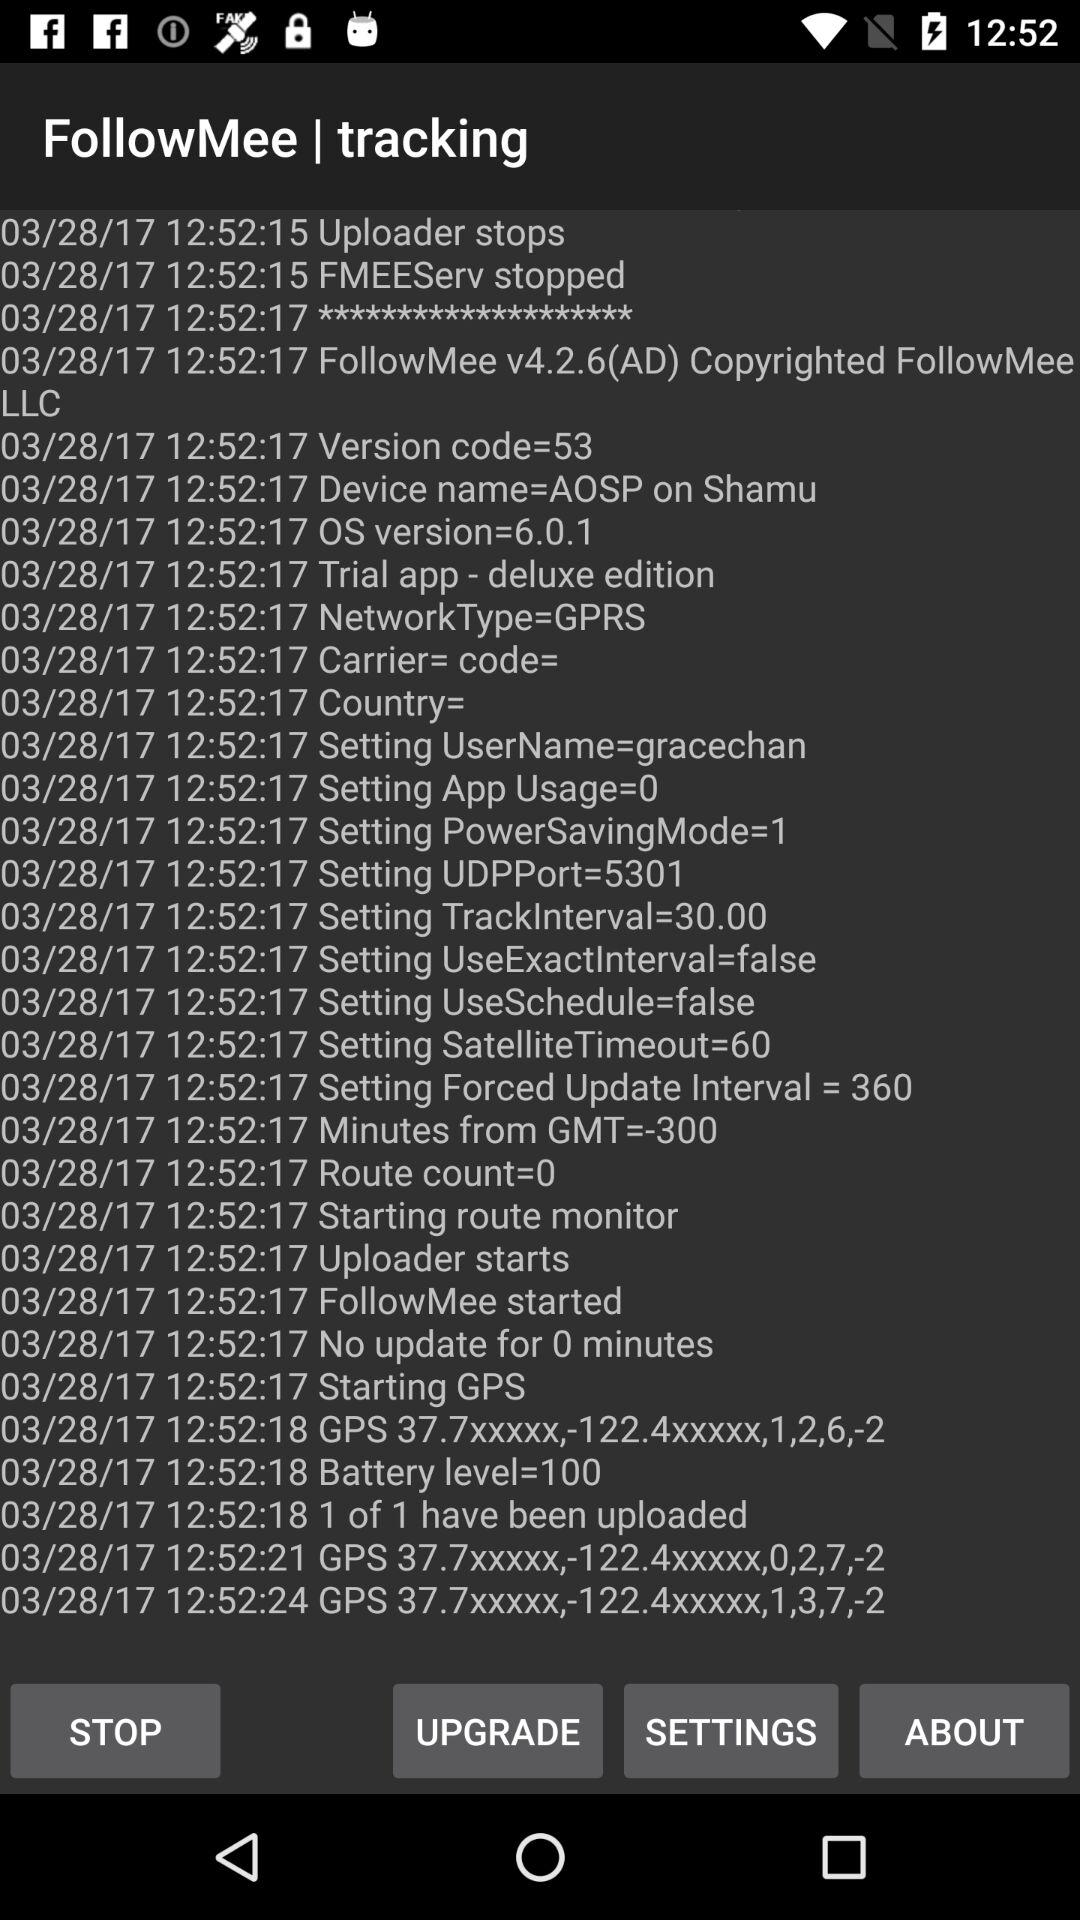What's the version code? The version code is 53. 